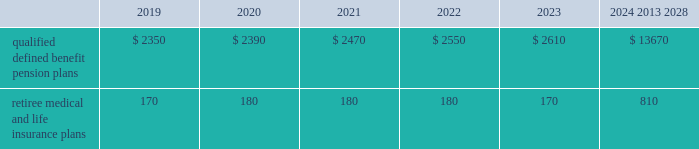Valuation techniques 2013 cash equivalents are mostly comprised of short-term money-market instruments and are valued at cost , which approximates fair value .
U.s .
Equity securities and international equity securities categorized as level 1 are traded on active national and international exchanges and are valued at their closing prices on the last trading day of the year .
For u.s .
Equity securities and international equity securities not traded on an active exchange , or if the closing price is not available , the trustee obtains indicative quotes from a pricing vendor , broker or investment manager .
These securities are categorized as level 2 if the custodian obtains corroborated quotes from a pricing vendor or categorized as level 3 if the custodian obtains uncorroborated quotes from a broker or investment manager .
Commingled equity funds categorized as level 1 are traded on active national and international exchanges and are valued at their closing prices on the last trading day of the year .
For commingled equity funds not traded on an active exchange , or if the closing price is not available , the trustee obtains indicative quotes from a pricing vendor , broker or investment manager .
These securities are categorized as level 2 if the custodian obtains corroborated quotes from a pricing vendor .
Fixed income investments categorized as level 2 are valued by the trustee using pricing models that use verifiable observable market data ( e.g. , interest rates and yield curves observable at commonly quoted intervals and credit spreads ) , bids provided by brokers or dealers or quoted prices of securities with similar characteristics .
Fixed income investments are categorized as level 3 when valuations using observable inputs are unavailable .
The trustee typically obtains pricing based on indicative quotes or bid evaluations from vendors , brokers or the investment manager .
In addition , certain other fixed income investments categorized as level 3 are valued using a discounted cash flow approach .
Significant inputs include projected annuity payments and the discount rate applied to those payments .
Certain commingled equity funds , consisting of equity mutual funds , are valued using the nav .
The nav valuations are based on the underlying investments and typically redeemable within 90 days .
Private equity funds consist of partnership and co-investment funds .
The nav is based on valuation models of the underlying securities , which includes unobservable inputs that cannot be corroborated using verifiable observable market data .
These funds typically have redemption periods between eight and 12 years .
Real estate funds consist of partnerships , most of which are closed-end funds , for which the nav is based on valuation models and periodic appraisals .
These funds typically have redemption periods between eight and 10 years .
Hedge funds consist of direct hedge funds for which the nav is generally based on the valuation of the underlying investments .
Redemptions in hedge funds are based on the specific terms of each fund , and generally range from a minimum of one month to several months .
Contributions and expected benefit payments the funding of our qualified defined benefit pension plans is determined in accordance with erisa , as amended by the ppa , and in a manner consistent with cas and internal revenue code rules .
We made contributions of $ 5.0 billion to our qualified defined benefit pension plans in 2018 , including required and discretionary contributions .
As a result of these contributions , we do not expect to make contributions to our qualified defined benefit pension plans in 2019 .
The table presents estimated future benefit payments , which reflect expected future employee service , as of december 31 , 2018 ( in millions ) : .
Defined contribution plans we maintain a number of defined contribution plans , most with 401 ( k ) features , that cover substantially all of our employees .
Under the provisions of our 401 ( k ) plans , we match most employees 2019 eligible contributions at rates specified in the plan documents .
Our contributions were $ 658 million in 2018 , $ 613 million in 2017 and $ 617 million in 2016 , the majority of which were funded using our common stock .
Our defined contribution plans held approximately 33.3 million and 35.5 million shares of our common stock as of december 31 , 2018 and 2017. .
In 2018 what was the ratio of the qualified defined benefit pension plans for the period starting after 2024 compared to 2019? 
Computations: (13670 / 2350)
Answer: 5.81702. 